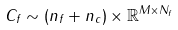<formula> <loc_0><loc_0><loc_500><loc_500>C _ { f } \sim ( n _ { f } + n _ { c } ) \times \mathbb { R } ^ { M \times N _ { f } }</formula> 